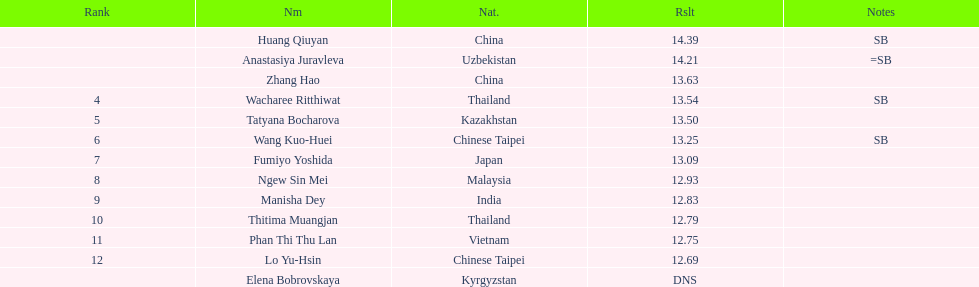How many contestants were from thailand? 2. 